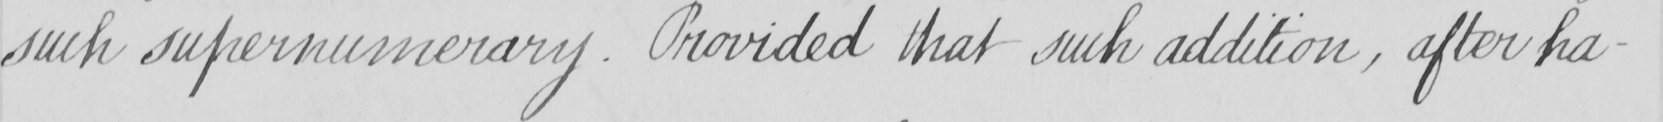What does this handwritten line say? such supernumerary . Provided that such addition , after ha- 